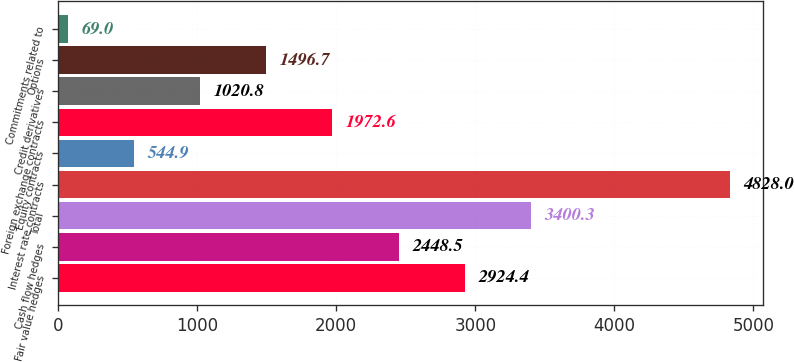Convert chart to OTSL. <chart><loc_0><loc_0><loc_500><loc_500><bar_chart><fcel>Fair value hedges<fcel>Cash flow hedges<fcel>Total<fcel>Interest rate contracts<fcel>Equity contracts<fcel>Foreign exchange contracts<fcel>Credit derivatives<fcel>Options<fcel>Commitments related to<nl><fcel>2924.4<fcel>2448.5<fcel>3400.3<fcel>4828<fcel>544.9<fcel>1972.6<fcel>1020.8<fcel>1496.7<fcel>69<nl></chart> 